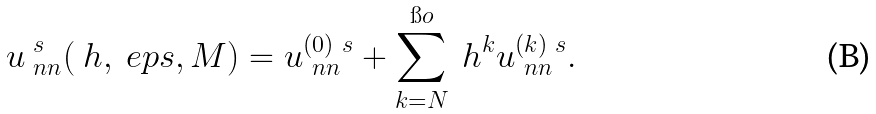Convert formula to latex. <formula><loc_0><loc_0><loc_500><loc_500>u ^ { \ s } _ { \ n n } ( \ h , \ e p s , M ) = u _ { \ n n } ^ { ( 0 ) \ s } + \sum _ { k = N } ^ { \i o } \ h ^ { k } u _ { \ n n } ^ { ( k ) \ s } .</formula> 